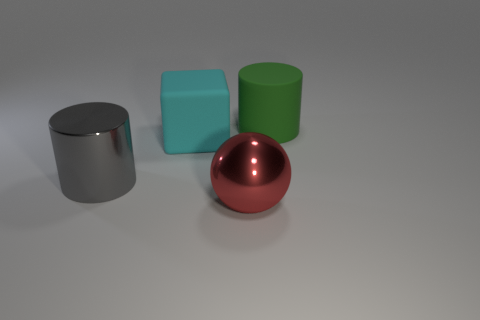Are any large cyan things visible?
Provide a succinct answer. Yes. There is a rubber object that is on the right side of the large matte thing in front of the green matte cylinder; is there a cylinder on the right side of it?
Your answer should be compact. No. Is there any other thing that is the same size as the block?
Your answer should be compact. Yes. Do the large gray shiny object and the large rubber object left of the green cylinder have the same shape?
Offer a terse response. No. What color is the matte thing left of the thing in front of the large cylinder in front of the large cube?
Provide a succinct answer. Cyan. What number of objects are shiny objects that are to the left of the ball or metal objects behind the red shiny ball?
Your answer should be compact. 1. What number of other things are there of the same color as the shiny ball?
Your answer should be compact. 0. Do the matte thing that is in front of the big rubber cylinder and the red object have the same shape?
Your response must be concise. No. Are there fewer matte cubes that are behind the cube than brown cylinders?
Offer a terse response. No. Are there any yellow cubes that have the same material as the red object?
Your answer should be compact. No. 